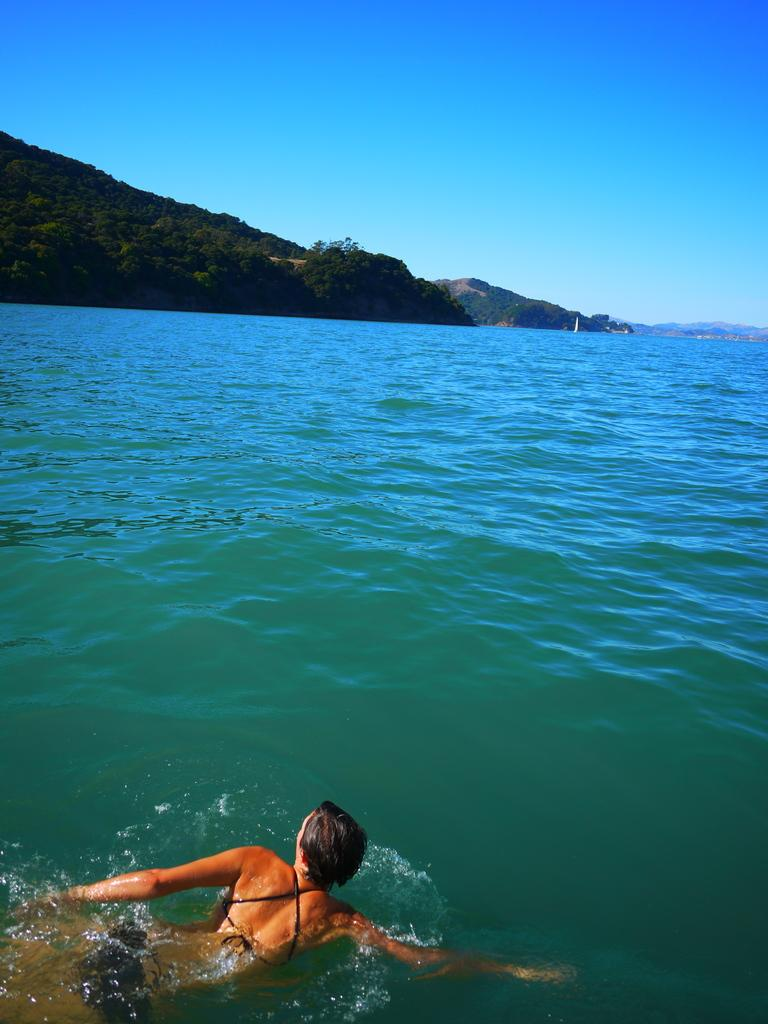What is the person in the image doing? There is a person swimming in the water in the image. What natural features can be seen in the background of the image? Mountains and trees are visible in the image. What is visible at the top of the image? The sky is visible at the top of the image. How much was the pancake payment for the person running in the image? There is no pancake or person running in the image, so it's not possible to determine any payment. 